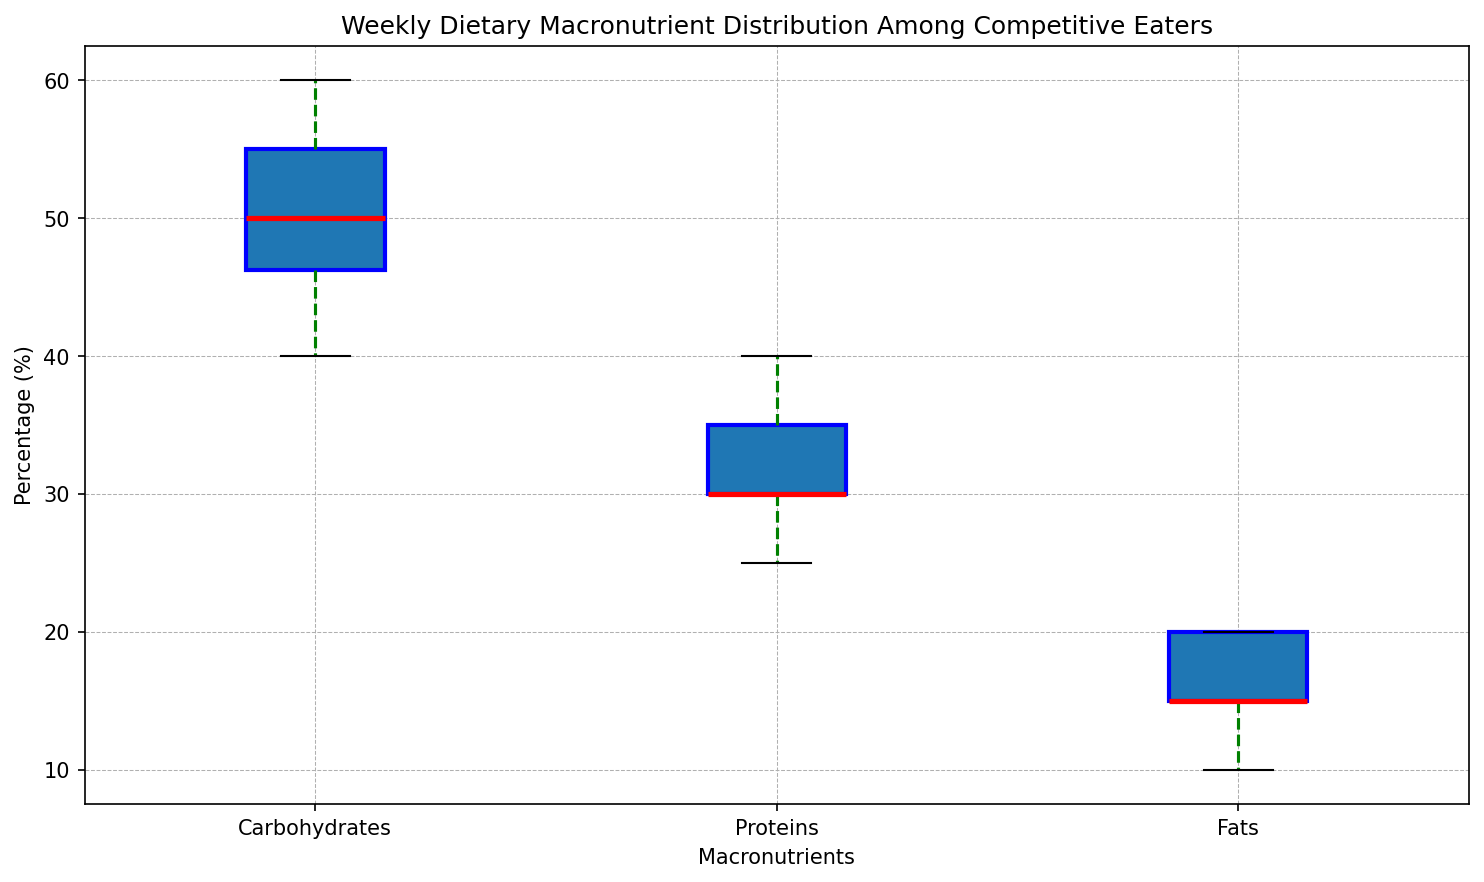What’s the median percentage of proteins consumed by competitive eaters? Identify the median line within the box plot for Proteins. The red line inside the box represents the median. Based on the visualization, the median protein consumption is 30%.
Answer: 30 Which macronutrient shows the highest variability in intake among competitive eaters? Assess the spread of each box plot. Carbohydrates exhibit the largest interquartile range (IQR), indicating higher variability.
Answer: Carbohydrates How does the interquartile range (IQR) for fats compare to that of proteins? The IQR is the width of the box from the 25th to the 75th percentile. For Fats, it is narrow, while for Proteins, it is broader. Proteins have a higher IQR than Fats.
Answer: Proteins have a higher IQR Which macronutrient has the smallest range of intake (whiskers' length)? Look at the length of whiskers for each macronutrient. Fats have the shortest whiskers, indicating the smallest range.
Answer: Fats Are there any outliers in the carbohydrate intake, and if so, how many? Outliers are represented as individual points outside the whiskers of the box plot. There are no outliers visible for Carbohydrates.
Answer: No What is the median percentage difference between Carbohydrates and Fats? Find the median for both Carbohydrates (55%) and Fats (15%). The difference is 55% - 15% = 40%.
Answer: 40% Which macronutrient has the highest median value? Compare the medians (red lines) of all three macronutrients in the plot. Carbohydrates have the highest median value.
Answer: Carbohydrates How do the 25th percentile values of Proteins compare to Carbohydrates? The bottom of the box indicates the 25th percentile. For Carbohydrates, it's around 45%, and for Proteins, it’s close to 30%.
Answer: Proteins have a lower 25th percentile Which macronutrient has the most consistent consumption among competitive eaters? Look at the spread and IQR of each macronutrient. Fats have the smallest spread and IQR, indicating the most consistent consumption.
Answer: Fats By how much does the upper quartile (75th percentile) intake of Proteins exceed that of Fats? Identify the 75th percentile for Proteins (approximately 35%) and for Fats (approximately 20%). The difference is 35% - 20% = 15%.
Answer: 15% 